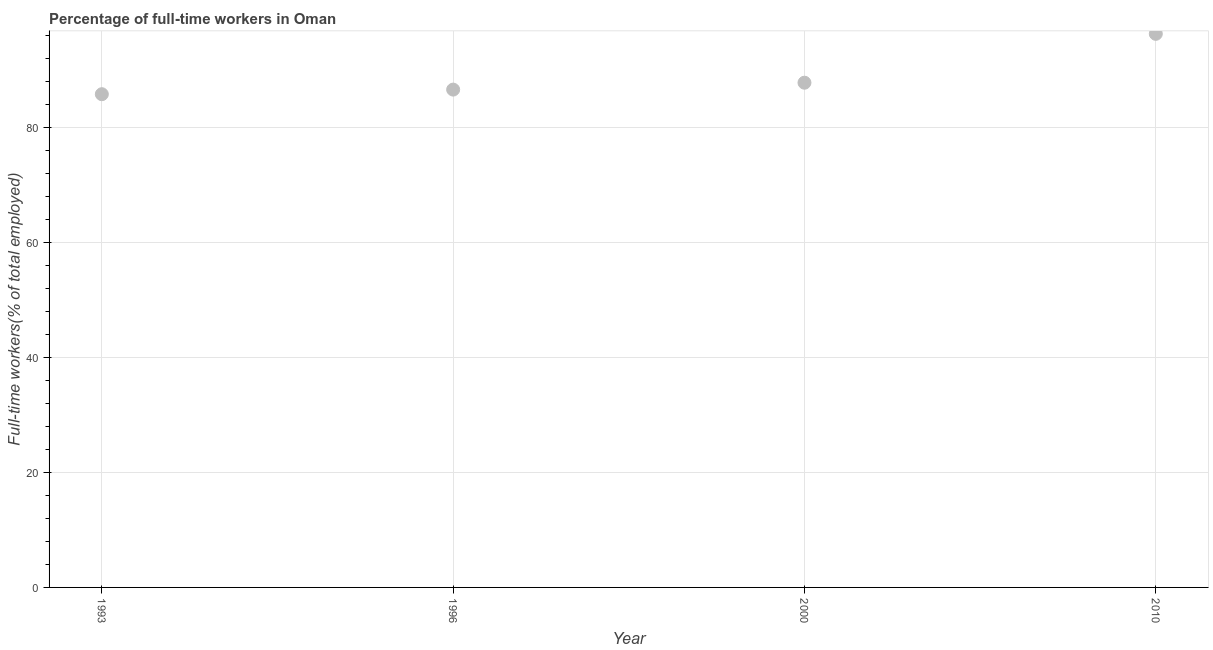What is the percentage of full-time workers in 1993?
Ensure brevity in your answer.  85.8. Across all years, what is the maximum percentage of full-time workers?
Your answer should be very brief. 96.3. Across all years, what is the minimum percentage of full-time workers?
Provide a short and direct response. 85.8. In which year was the percentage of full-time workers maximum?
Ensure brevity in your answer.  2010. In which year was the percentage of full-time workers minimum?
Keep it short and to the point. 1993. What is the sum of the percentage of full-time workers?
Offer a terse response. 356.5. What is the difference between the percentage of full-time workers in 1993 and 1996?
Ensure brevity in your answer.  -0.8. What is the average percentage of full-time workers per year?
Give a very brief answer. 89.13. What is the median percentage of full-time workers?
Ensure brevity in your answer.  87.2. In how many years, is the percentage of full-time workers greater than 48 %?
Provide a succinct answer. 4. What is the ratio of the percentage of full-time workers in 1996 to that in 2010?
Offer a very short reply. 0.9. Is the percentage of full-time workers in 1993 less than that in 2010?
Make the answer very short. Yes. Is the difference between the percentage of full-time workers in 1993 and 1996 greater than the difference between any two years?
Your answer should be compact. No. What is the difference between the highest and the lowest percentage of full-time workers?
Give a very brief answer. 10.5. In how many years, is the percentage of full-time workers greater than the average percentage of full-time workers taken over all years?
Make the answer very short. 1. Does the percentage of full-time workers monotonically increase over the years?
Your answer should be very brief. Yes. Does the graph contain grids?
Ensure brevity in your answer.  Yes. What is the title of the graph?
Your answer should be compact. Percentage of full-time workers in Oman. What is the label or title of the X-axis?
Offer a very short reply. Year. What is the label or title of the Y-axis?
Provide a succinct answer. Full-time workers(% of total employed). What is the Full-time workers(% of total employed) in 1993?
Make the answer very short. 85.8. What is the Full-time workers(% of total employed) in 1996?
Ensure brevity in your answer.  86.6. What is the Full-time workers(% of total employed) in 2000?
Offer a very short reply. 87.8. What is the Full-time workers(% of total employed) in 2010?
Give a very brief answer. 96.3. What is the difference between the Full-time workers(% of total employed) in 1993 and 2000?
Provide a succinct answer. -2. What is the difference between the Full-time workers(% of total employed) in 1996 and 2010?
Ensure brevity in your answer.  -9.7. What is the ratio of the Full-time workers(% of total employed) in 1993 to that in 2010?
Offer a very short reply. 0.89. What is the ratio of the Full-time workers(% of total employed) in 1996 to that in 2000?
Your answer should be very brief. 0.99. What is the ratio of the Full-time workers(% of total employed) in 1996 to that in 2010?
Make the answer very short. 0.9. What is the ratio of the Full-time workers(% of total employed) in 2000 to that in 2010?
Give a very brief answer. 0.91. 